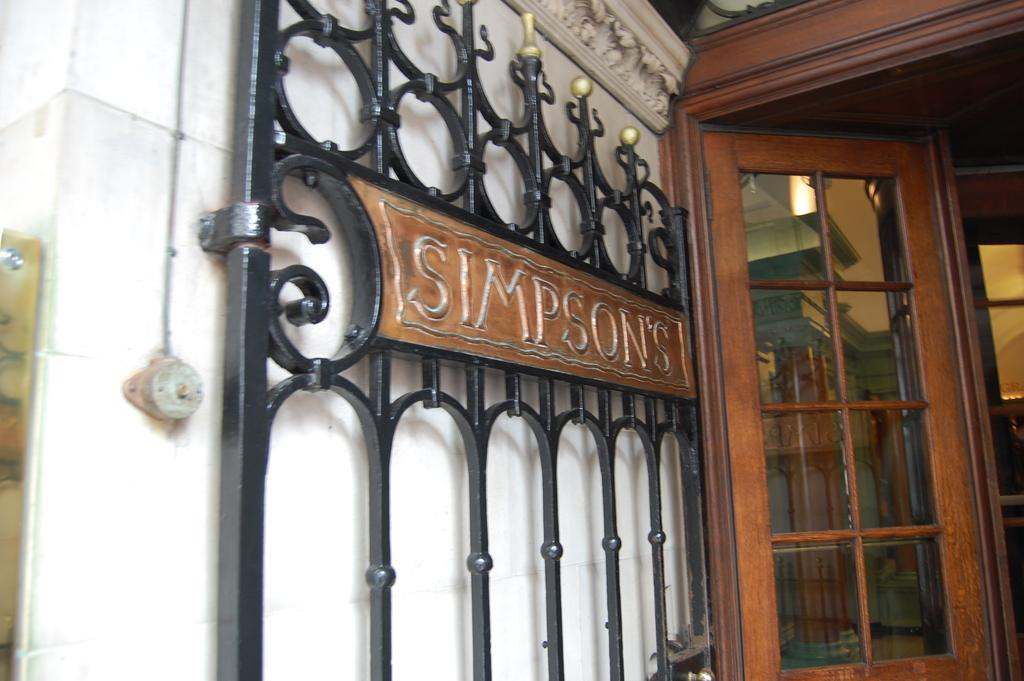What structure is located on the left side of the image? There is a wall on the left side of the image. What can be seen in the image besides the wall? There is a gate and a door in the image. Can you describe the door in the image? The door has a glass panel. What type of pump is visible near the door in the image? There is no pump present in the image. What emotion is being expressed by the door in the image? Doors do not express emotions, so this question cannot be answered. 